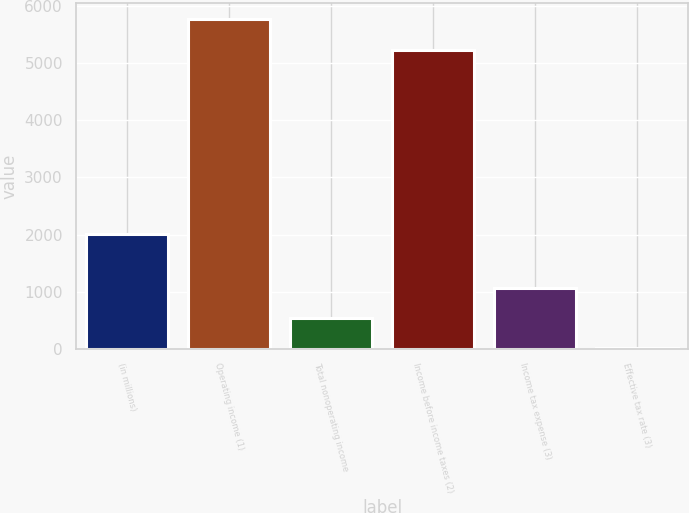Convert chart. <chart><loc_0><loc_0><loc_500><loc_500><bar_chart><fcel>(in millions)<fcel>Operating income (1)<fcel>Total nonoperating income<fcel>Income before income taxes (2)<fcel>Income tax expense (3)<fcel>Effective tax rate (3)<nl><fcel>2017<fcel>5766.68<fcel>531.88<fcel>5240<fcel>1058.56<fcel>5.2<nl></chart> 